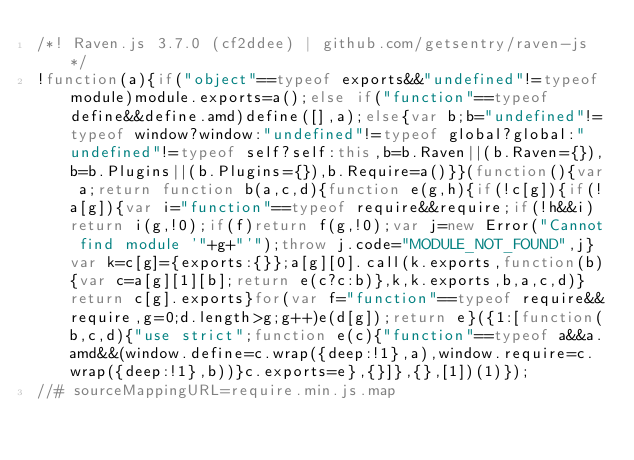Convert code to text. <code><loc_0><loc_0><loc_500><loc_500><_JavaScript_>/*! Raven.js 3.7.0 (cf2ddee) | github.com/getsentry/raven-js */
!function(a){if("object"==typeof exports&&"undefined"!=typeof module)module.exports=a();else if("function"==typeof define&&define.amd)define([],a);else{var b;b="undefined"!=typeof window?window:"undefined"!=typeof global?global:"undefined"!=typeof self?self:this,b=b.Raven||(b.Raven={}),b=b.Plugins||(b.Plugins={}),b.Require=a()}}(function(){var a;return function b(a,c,d){function e(g,h){if(!c[g]){if(!a[g]){var i="function"==typeof require&&require;if(!h&&i)return i(g,!0);if(f)return f(g,!0);var j=new Error("Cannot find module '"+g+"'");throw j.code="MODULE_NOT_FOUND",j}var k=c[g]={exports:{}};a[g][0].call(k.exports,function(b){var c=a[g][1][b];return e(c?c:b)},k,k.exports,b,a,c,d)}return c[g].exports}for(var f="function"==typeof require&&require,g=0;d.length>g;g++)e(d[g]);return e}({1:[function(b,c,d){"use strict";function e(c){"function"==typeof a&&a.amd&&(window.define=c.wrap({deep:!1},a),window.require=c.wrap({deep:!1},b))}c.exports=e},{}]},{},[1])(1)});
//# sourceMappingURL=require.min.js.map</code> 